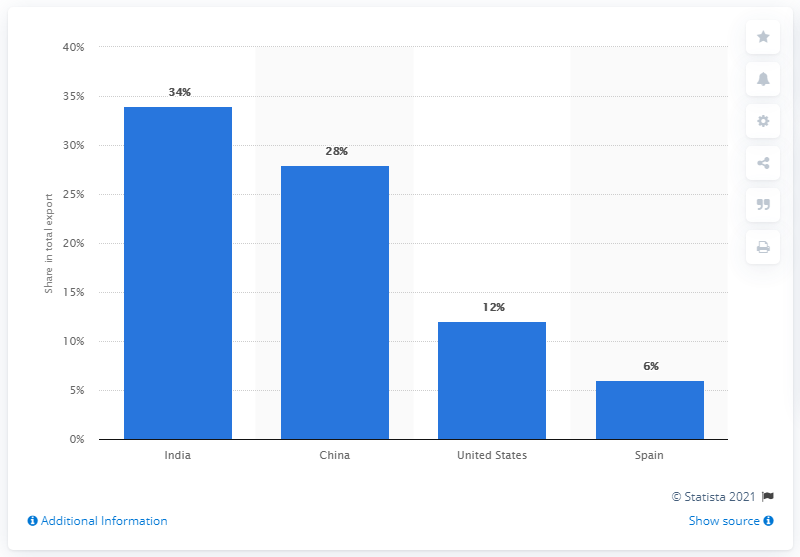Indicate a few pertinent items in this graphic. The average of all numbers 20 and below is [objective value]. In 2019, India was Venezuela's most important export partner. The United States is a country that is below 25%, but not the least, in terms of its contributions to the world. 